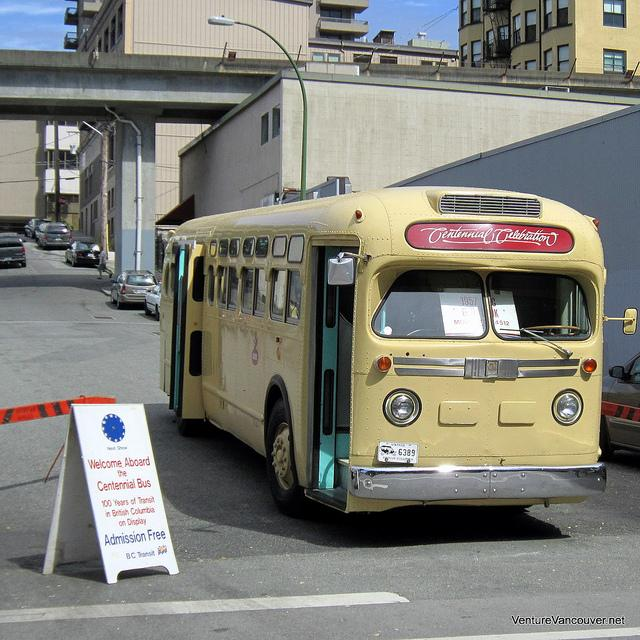This bus is part of what? Please explain your reasoning. exhibition. This bus is part of a bus exhibition as is read from the sign. 